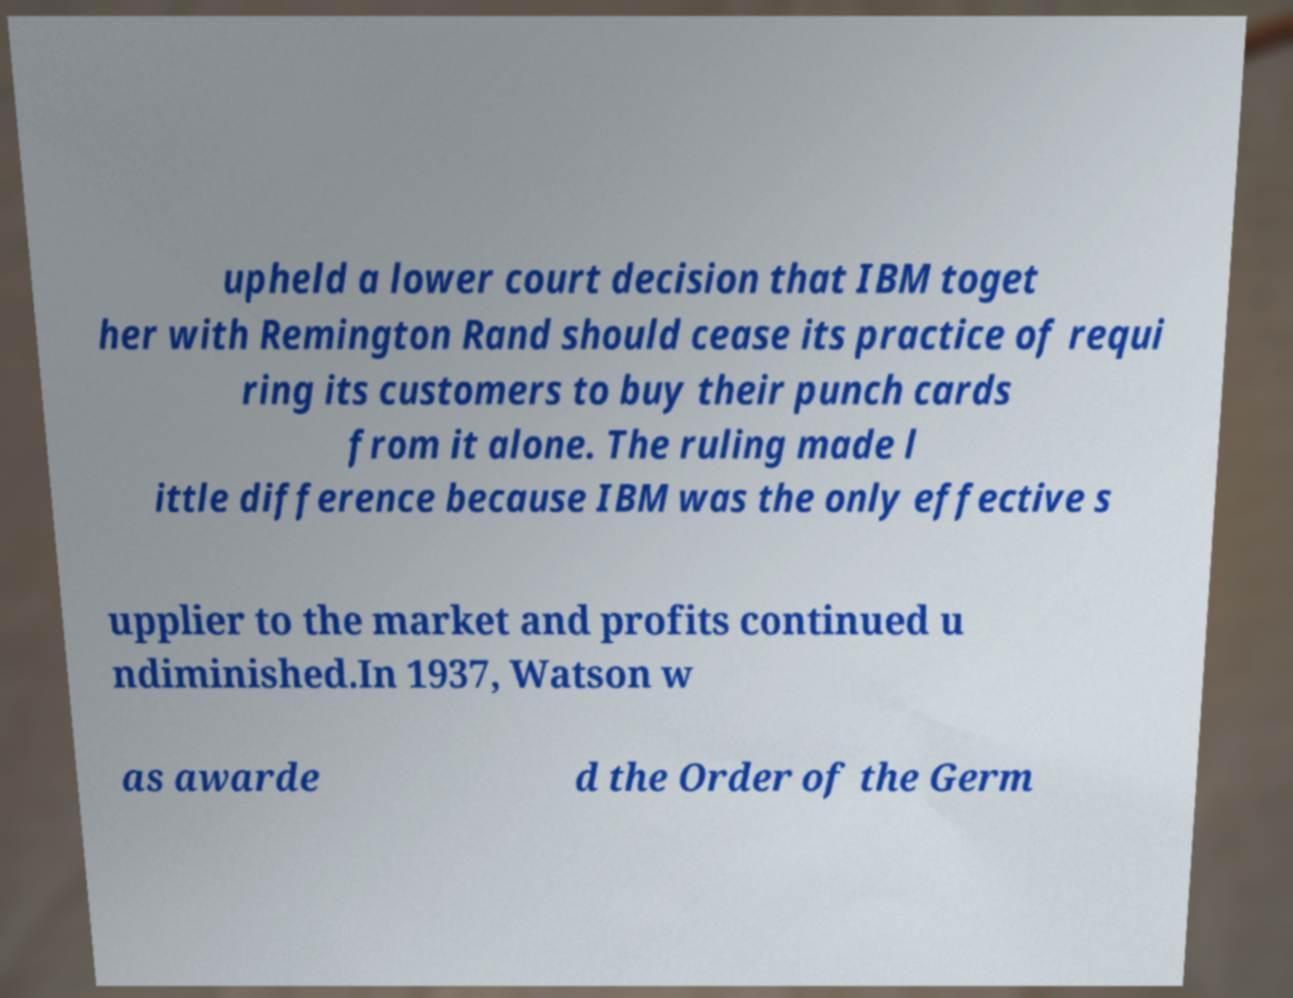Can you accurately transcribe the text from the provided image for me? upheld a lower court decision that IBM toget her with Remington Rand should cease its practice of requi ring its customers to buy their punch cards from it alone. The ruling made l ittle difference because IBM was the only effective s upplier to the market and profits continued u ndiminished.In 1937, Watson w as awarde d the Order of the Germ 